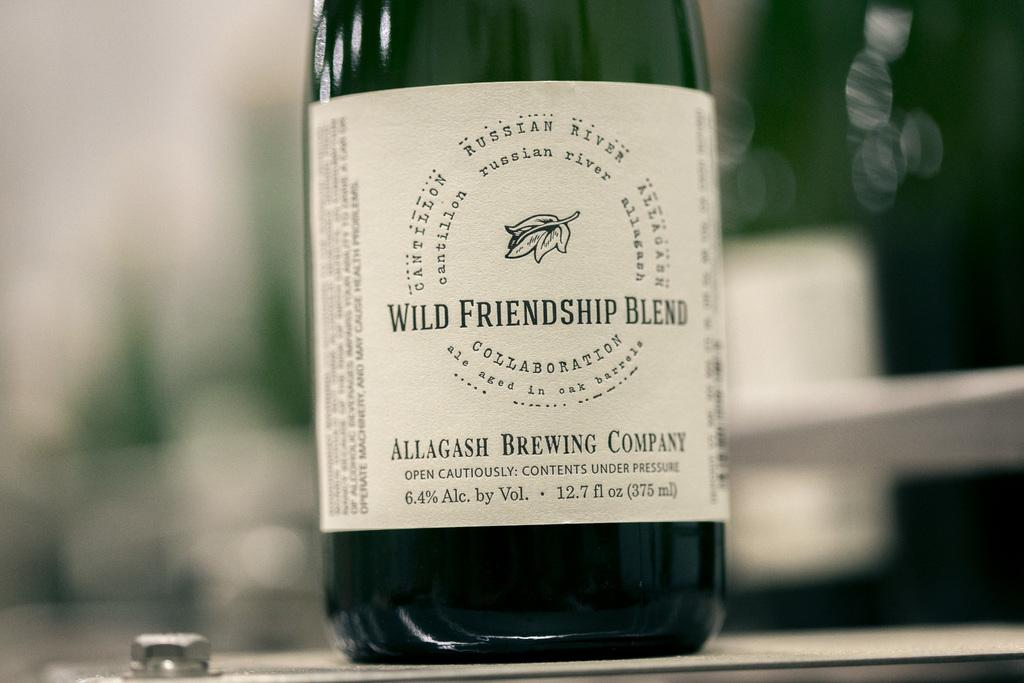<image>
Render a clear and concise summary of the photo. the word wild that is on a wine bottle 